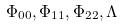Convert formula to latex. <formula><loc_0><loc_0><loc_500><loc_500>\Phi _ { 0 0 } , \Phi _ { 1 1 } , \Phi _ { 2 2 } , \Lambda</formula> 